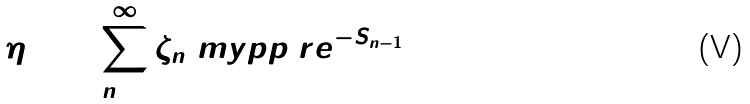Convert formula to latex. <formula><loc_0><loc_0><loc_500><loc_500>\eta \colon = \sum _ { n = 1 } ^ { \infty } \zeta _ { n } \ m y p p \ r e ^ { - S _ { n - 1 } }</formula> 